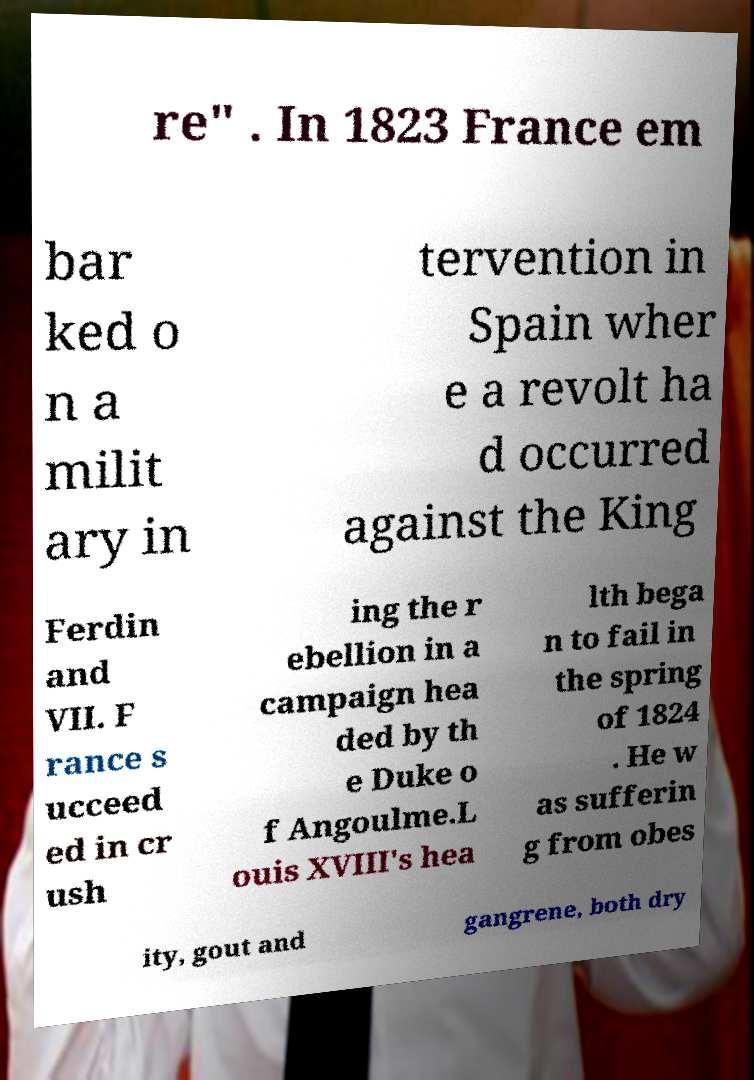Please read and relay the text visible in this image. What does it say? re" . In 1823 France em bar ked o n a milit ary in tervention in Spain wher e a revolt ha d occurred against the King Ferdin and VII. F rance s ucceed ed in cr ush ing the r ebellion in a campaign hea ded by th e Duke o f Angoulme.L ouis XVIII's hea lth bega n to fail in the spring of 1824 . He w as sufferin g from obes ity, gout and gangrene, both dry 